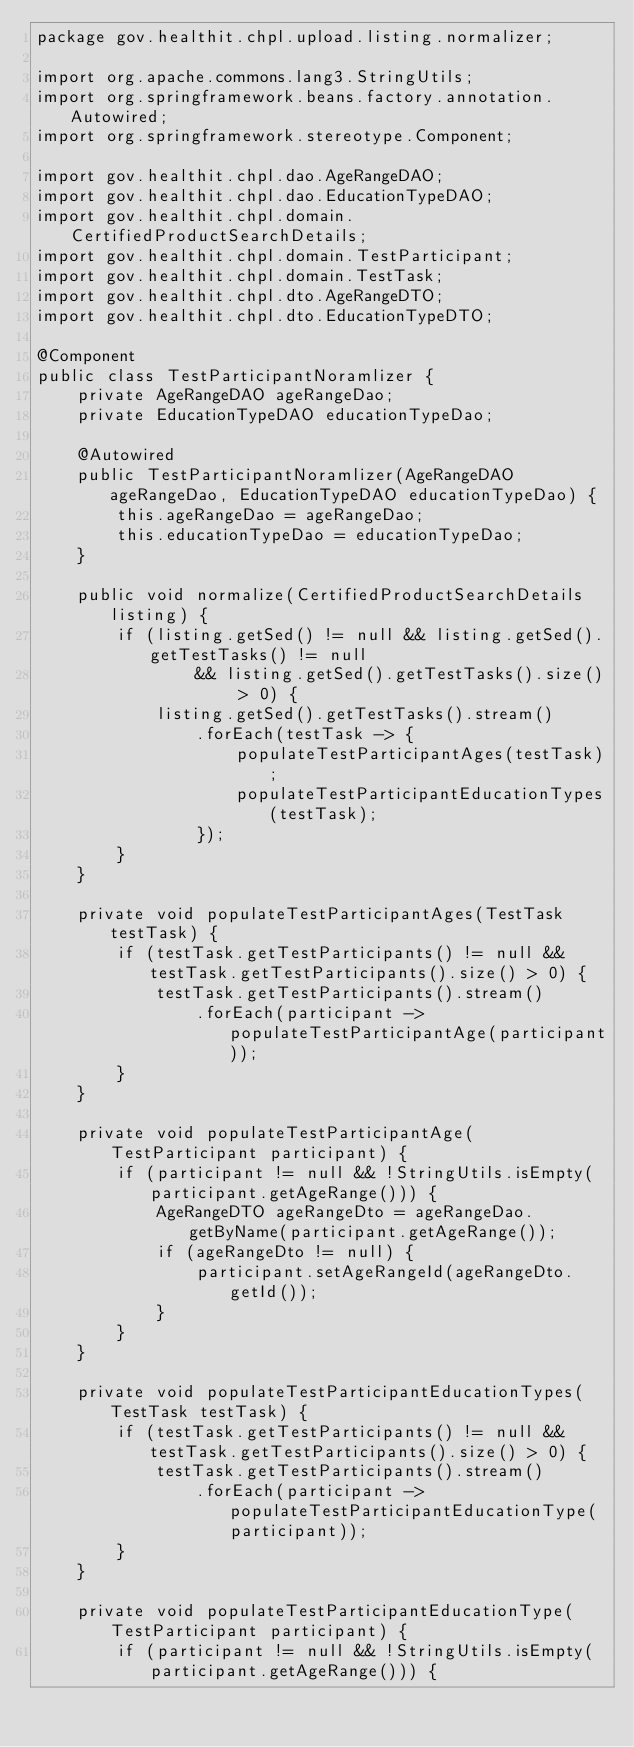<code> <loc_0><loc_0><loc_500><loc_500><_Java_>package gov.healthit.chpl.upload.listing.normalizer;

import org.apache.commons.lang3.StringUtils;
import org.springframework.beans.factory.annotation.Autowired;
import org.springframework.stereotype.Component;

import gov.healthit.chpl.dao.AgeRangeDAO;
import gov.healthit.chpl.dao.EducationTypeDAO;
import gov.healthit.chpl.domain.CertifiedProductSearchDetails;
import gov.healthit.chpl.domain.TestParticipant;
import gov.healthit.chpl.domain.TestTask;
import gov.healthit.chpl.dto.AgeRangeDTO;
import gov.healthit.chpl.dto.EducationTypeDTO;

@Component
public class TestParticipantNoramlizer {
    private AgeRangeDAO ageRangeDao;
    private EducationTypeDAO educationTypeDao;

    @Autowired
    public TestParticipantNoramlizer(AgeRangeDAO ageRangeDao, EducationTypeDAO educationTypeDao) {
        this.ageRangeDao = ageRangeDao;
        this.educationTypeDao = educationTypeDao;
    }

    public void normalize(CertifiedProductSearchDetails listing) {
        if (listing.getSed() != null && listing.getSed().getTestTasks() != null
                && listing.getSed().getTestTasks().size() > 0) {
            listing.getSed().getTestTasks().stream()
                .forEach(testTask -> {
                    populateTestParticipantAges(testTask);
                    populateTestParticipantEducationTypes(testTask);
                });
        }
    }

    private void populateTestParticipantAges(TestTask testTask) {
        if (testTask.getTestParticipants() != null && testTask.getTestParticipants().size() > 0) {
            testTask.getTestParticipants().stream()
                .forEach(participant -> populateTestParticipantAge(participant));
        }
    }

    private void populateTestParticipantAge(TestParticipant participant) {
        if (participant != null && !StringUtils.isEmpty(participant.getAgeRange())) {
            AgeRangeDTO ageRangeDto = ageRangeDao.getByName(participant.getAgeRange());
            if (ageRangeDto != null) {
                participant.setAgeRangeId(ageRangeDto.getId());
            }
        }
    }

    private void populateTestParticipantEducationTypes(TestTask testTask) {
        if (testTask.getTestParticipants() != null && testTask.getTestParticipants().size() > 0) {
            testTask.getTestParticipants().stream()
                .forEach(participant -> populateTestParticipantEducationType(participant));
        }
    }

    private void populateTestParticipantEducationType(TestParticipant participant) {
        if (participant != null && !StringUtils.isEmpty(participant.getAgeRange())) {</code> 